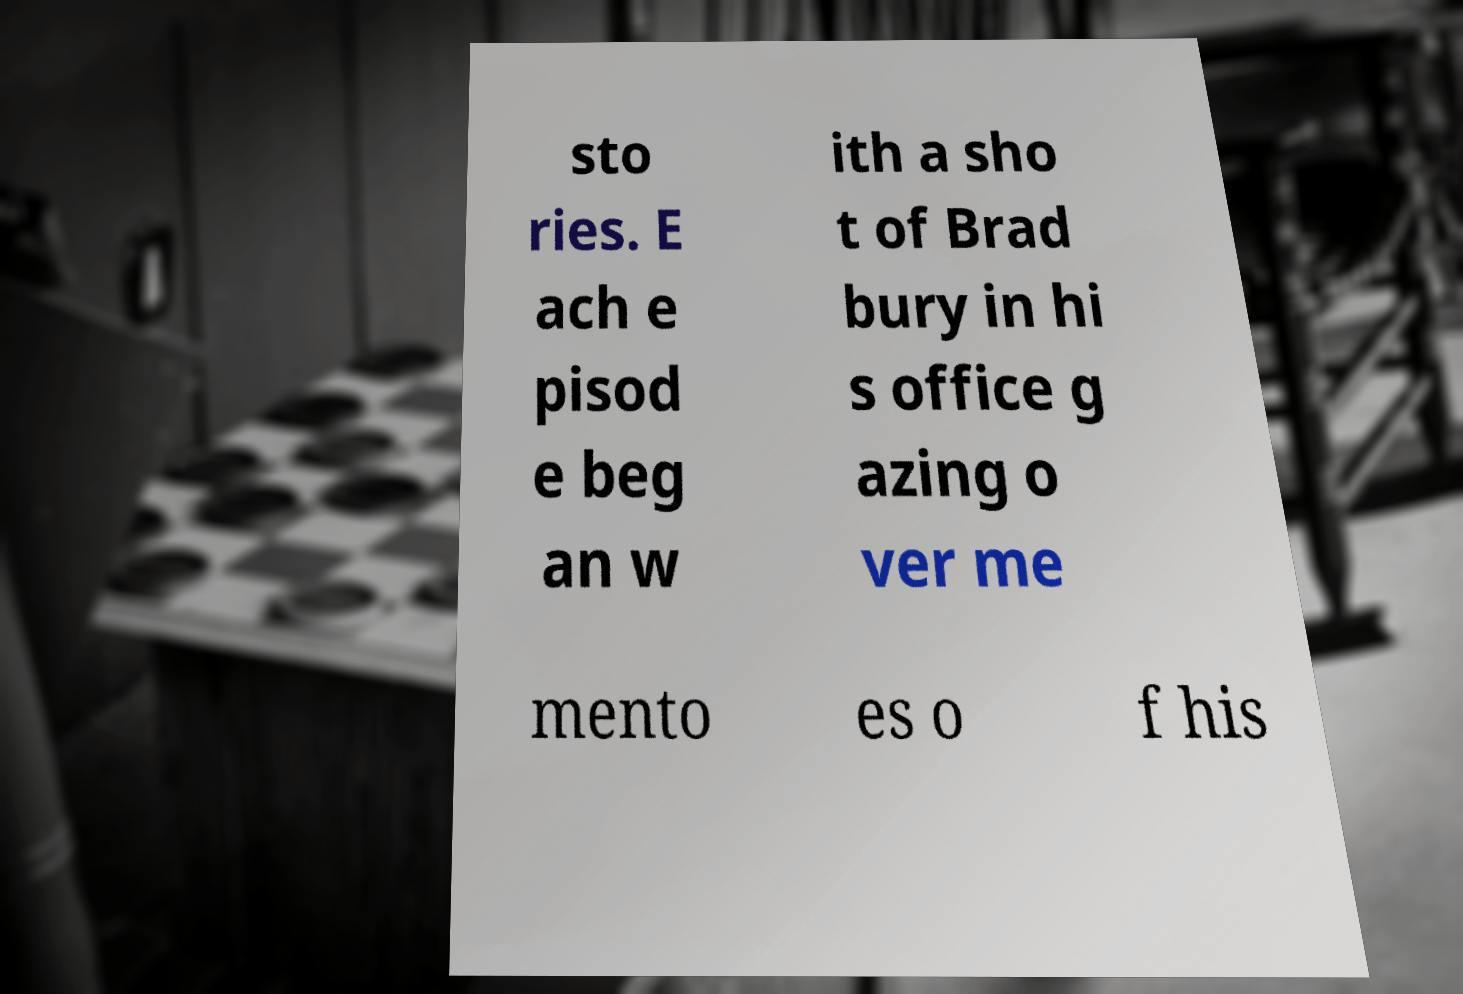Please read and relay the text visible in this image. What does it say? sto ries. E ach e pisod e beg an w ith a sho t of Brad bury in hi s office g azing o ver me mento es o f his 